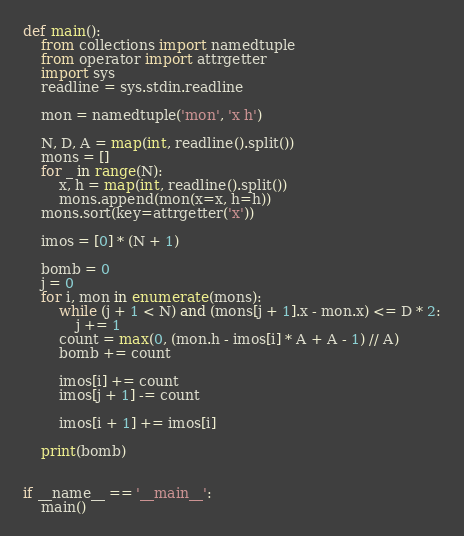<code> <loc_0><loc_0><loc_500><loc_500><_Python_>def main():
    from collections import namedtuple
    from operator import attrgetter
    import sys
    readline = sys.stdin.readline

    mon = namedtuple('mon', 'x h')

    N, D, A = map(int, readline().split())
    mons = []
    for _ in range(N):
        x, h = map(int, readline().split())
        mons.append(mon(x=x, h=h))
    mons.sort(key=attrgetter('x'))

    imos = [0] * (N + 1)

    bomb = 0
    j = 0
    for i, mon in enumerate(mons):
        while (j + 1 < N) and (mons[j + 1].x - mon.x) <= D * 2:
            j += 1
        count = max(0, (mon.h - imos[i] * A + A - 1) // A)
        bomb += count

        imos[i] += count
        imos[j + 1] -= count

        imos[i + 1] += imos[i]

    print(bomb)


if __name__ == '__main__':
    main()
</code> 